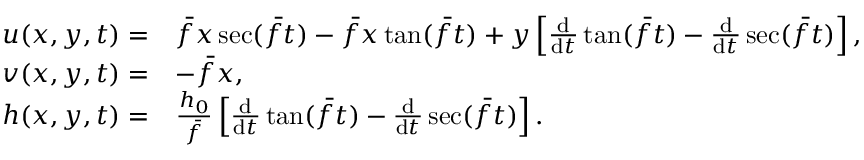Convert formula to latex. <formula><loc_0><loc_0><loc_500><loc_500>\begin{array} { r l } { u ( x , y , t ) = } & { \bar { f } x \sec ( \bar { f } t ) - \bar { f } x \tan ( \bar { f } t ) + y \left [ \frac { d } { d t } \tan ( \bar { f } t ) - \frac { d } { d t } \sec ( \bar { f } t ) \right ] , } \\ { v ( x , y , t ) = } & { - \bar { f } x , } \\ { h ( x , y , t ) = } & { \frac { h _ { 0 } } { \bar { f } } \left [ \frac { d } { d t } \tan ( \bar { f } t ) - \frac { d } { d t } \sec ( \bar { f } t ) \right ] . } \end{array}</formula> 